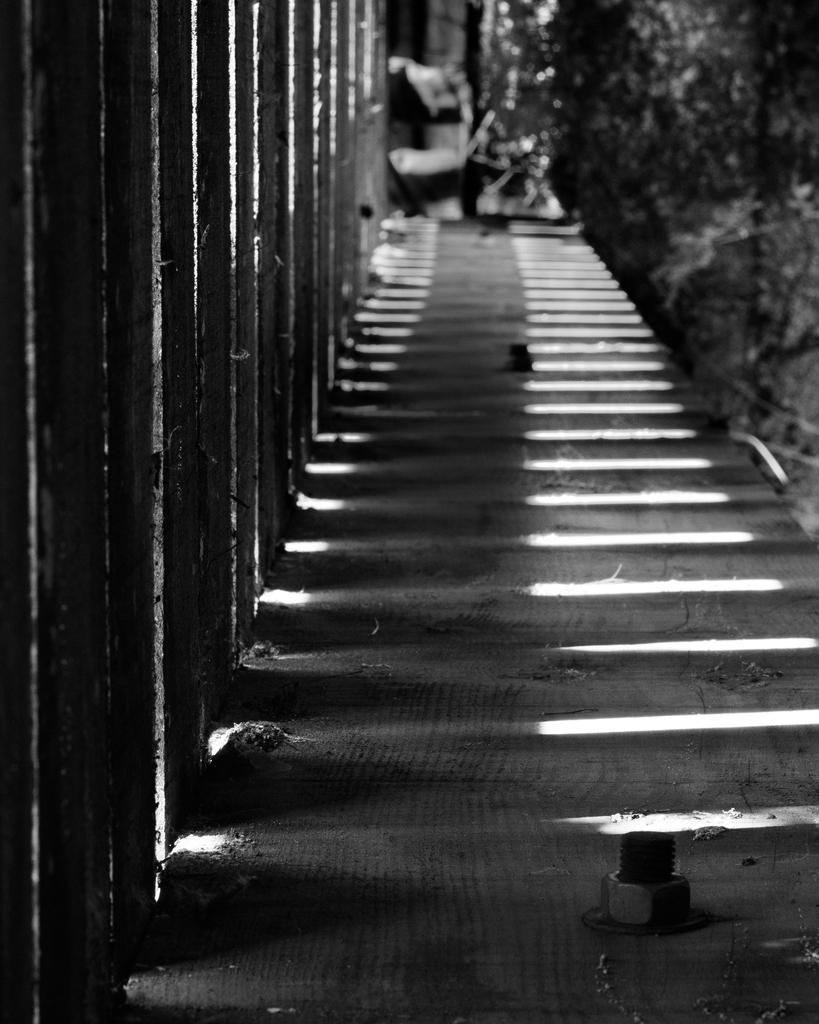Can you describe this image briefly? This is a black and white image. Here I can see the stairs. On the left side, I can see the railing and on the right side, I can see few plants. 